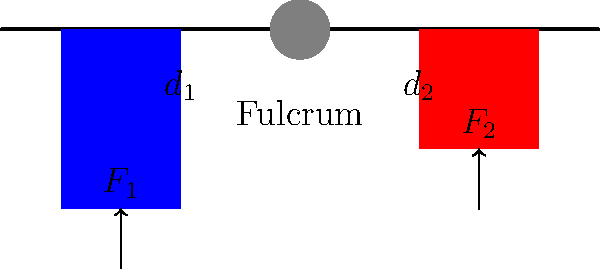In the context of international diplomacy, consider the lever system shown above as a metaphor for balancing competing interests. If $F_1$ represents the influence of your country and $F_2$ represents the influence of a rival nation, with $d_1 = 40$ cm and $d_2 = 20$ cm, what magnitude of $F_2$ is required to balance a force $F_1 = 100$ N? Assume the lever is in equilibrium. To solve this problem, we'll use the principle of moments, which is analogous to balancing diplomatic influences:

1. In a lever system, equilibrium is achieved when the sum of moments about the fulcrum is zero.

2. The moment of a force is calculated as the product of the force and its perpendicular distance from the fulcrum.

3. For our system, we can write:
   $$F_1 \times d_1 = F_2 \times d_2$$

4. We're given:
   $F_1 = 100$ N
   $d_1 = 40$ cm
   $d_2 = 20$ cm

5. Substituting these values:
   $$100 \text{ N} \times 40 \text{ cm} = F_2 \times 20 \text{ cm}$$

6. Simplifying:
   $$4000 \text{ N}\cdot\text{cm} = F_2 \times 20 \text{ cm}$$

7. Solving for $F_2$:
   $$F_2 = \frac{4000 \text{ N}\cdot\text{cm}}{20 \text{ cm}} = 200 \text{ N}$$

This result demonstrates that in diplomacy, as in physics, a smaller influence (force) can balance a larger one if it's applied at a greater distance (leverage) from the point of decision (fulcrum).
Answer: $200$ N 